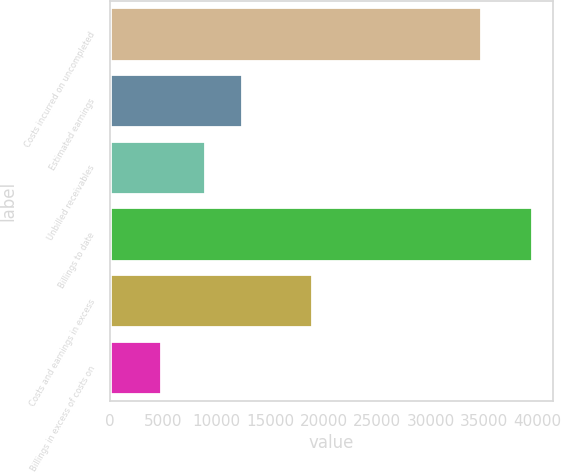<chart> <loc_0><loc_0><loc_500><loc_500><bar_chart><fcel>Costs incurred on uncompleted<fcel>Estimated earnings<fcel>Unbilled receivables<fcel>Billings to date<fcel>Costs and earnings in excess<fcel>Billings in excess of costs on<nl><fcel>34748<fcel>12330.7<fcel>8863<fcel>39469<fcel>18894<fcel>4792<nl></chart> 